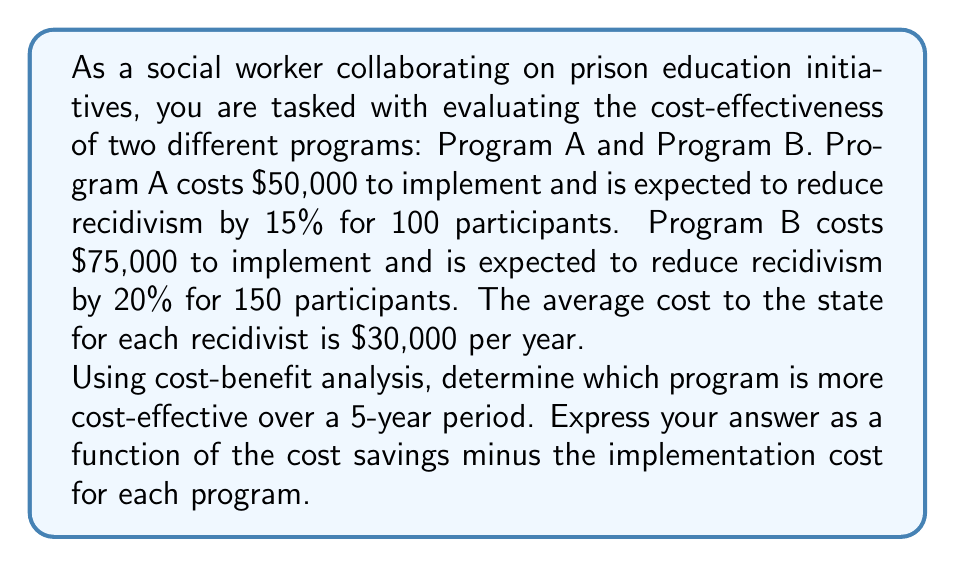Provide a solution to this math problem. To determine the cost-effectiveness of each program, we need to calculate the cost savings from reduced recidivism and subtract the implementation cost. Let's break this down step-by-step:

1. Calculate the number of participants who won't recidivate for each program:
   Program A: $100 \times 15\% = 15$ participants
   Program B: $150 \times 20\% = 30$ participants

2. Calculate the cost savings over 5 years for each program:
   Cost savings = Number of non-recidivists × Cost per recidivist × Number of years
   Program A: $15 \times \$30,000 \times 5 = \$2,250,000$
   Program B: $30 \times \$30,000 \times 5 = \$4,500,000$

3. Define cost-effectiveness functions for each program:
   Let $C_A(t)$ be the cost-effectiveness of Program A after $t$ years
   Let $C_B(t)$ be the cost-effectiveness of Program B after $t$ years

   $$C_A(t) = 450,000t - 50,000$$
   $$C_B(t) = 900,000t - 75,000$$

4. Evaluate the functions for $t = 5$ years:
   $$C_A(5) = 450,000(5) - 50,000 = 2,200,000$$
   $$C_B(5) = 900,000(5) - 75,000 = 4,425,000$$

5. Compare the results:
   Program B is more cost-effective over a 5-year period, with a net benefit of $4,425,000 compared to Program A's $2,200,000.
Answer: Program B is more cost-effective. The cost-effectiveness functions are:
$$C_A(t) = 450,000t - 50,000$$
$$C_B(t) = 900,000t - 75,000$$
For $t = 5$ years, $C_B(5) = \$4,425,000 > C_A(5) = \$2,200,000$ 